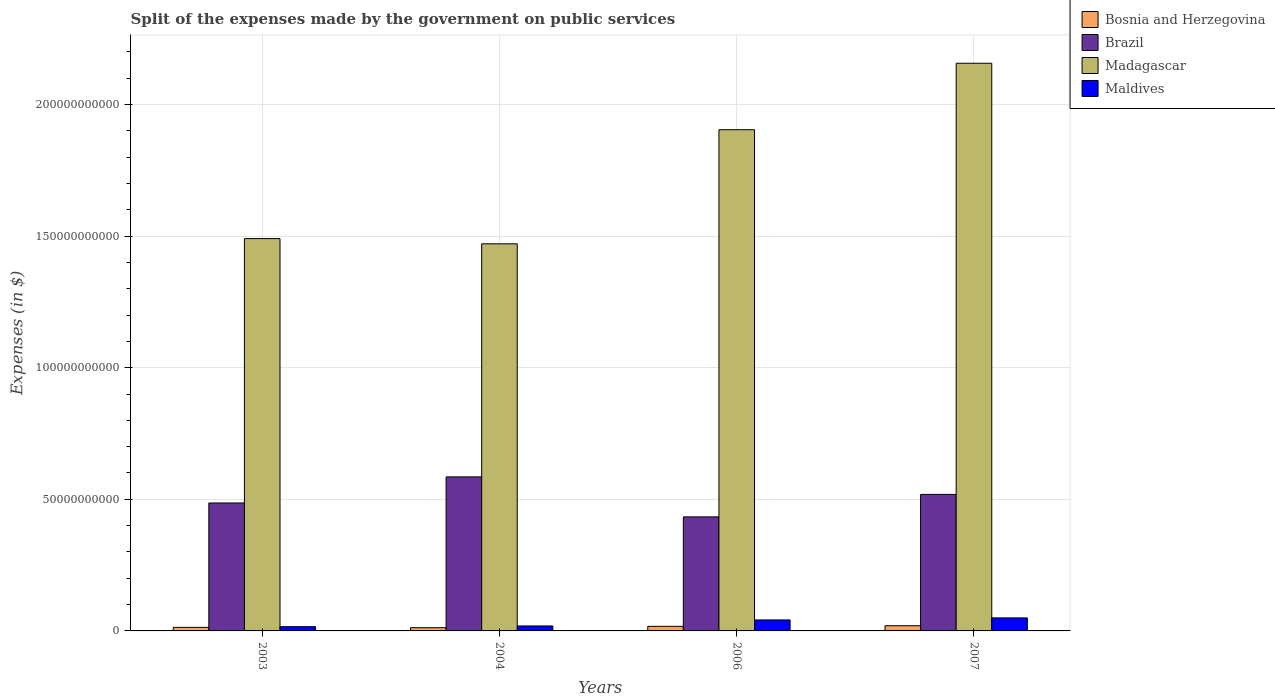How many groups of bars are there?
Provide a succinct answer. 4. Are the number of bars per tick equal to the number of legend labels?
Offer a very short reply. Yes. How many bars are there on the 3rd tick from the right?
Keep it short and to the point. 4. In how many cases, is the number of bars for a given year not equal to the number of legend labels?
Provide a short and direct response. 0. What is the expenses made by the government on public services in Maldives in 2004?
Give a very brief answer. 1.88e+09. Across all years, what is the maximum expenses made by the government on public services in Brazil?
Keep it short and to the point. 5.85e+1. Across all years, what is the minimum expenses made by the government on public services in Madagascar?
Offer a terse response. 1.47e+11. In which year was the expenses made by the government on public services in Madagascar minimum?
Make the answer very short. 2004. What is the total expenses made by the government on public services in Madagascar in the graph?
Ensure brevity in your answer.  7.02e+11. What is the difference between the expenses made by the government on public services in Madagascar in 2006 and that in 2007?
Your response must be concise. -2.52e+1. What is the difference between the expenses made by the government on public services in Brazil in 2007 and the expenses made by the government on public services in Bosnia and Herzegovina in 2003?
Ensure brevity in your answer.  5.05e+1. What is the average expenses made by the government on public services in Bosnia and Herzegovina per year?
Offer a terse response. 1.57e+09. In the year 2006, what is the difference between the expenses made by the government on public services in Brazil and expenses made by the government on public services in Bosnia and Herzegovina?
Your answer should be compact. 4.16e+1. In how many years, is the expenses made by the government on public services in Madagascar greater than 180000000000 $?
Ensure brevity in your answer.  2. What is the ratio of the expenses made by the government on public services in Brazil in 2006 to that in 2007?
Your answer should be very brief. 0.84. Is the expenses made by the government on public services in Maldives in 2006 less than that in 2007?
Offer a very short reply. Yes. Is the difference between the expenses made by the government on public services in Brazil in 2003 and 2004 greater than the difference between the expenses made by the government on public services in Bosnia and Herzegovina in 2003 and 2004?
Your answer should be compact. No. What is the difference between the highest and the second highest expenses made by the government on public services in Brazil?
Ensure brevity in your answer.  6.65e+09. What is the difference between the highest and the lowest expenses made by the government on public services in Madagascar?
Offer a very short reply. 6.86e+1. In how many years, is the expenses made by the government on public services in Madagascar greater than the average expenses made by the government on public services in Madagascar taken over all years?
Your answer should be compact. 2. Is it the case that in every year, the sum of the expenses made by the government on public services in Madagascar and expenses made by the government on public services in Bosnia and Herzegovina is greater than the sum of expenses made by the government on public services in Maldives and expenses made by the government on public services in Brazil?
Provide a short and direct response. Yes. What does the 4th bar from the right in 2003 represents?
Your response must be concise. Bosnia and Herzegovina. Is it the case that in every year, the sum of the expenses made by the government on public services in Maldives and expenses made by the government on public services in Brazil is greater than the expenses made by the government on public services in Madagascar?
Give a very brief answer. No. Are all the bars in the graph horizontal?
Give a very brief answer. No. Where does the legend appear in the graph?
Your answer should be very brief. Top right. How many legend labels are there?
Your answer should be compact. 4. How are the legend labels stacked?
Your response must be concise. Vertical. What is the title of the graph?
Ensure brevity in your answer.  Split of the expenses made by the government on public services. What is the label or title of the Y-axis?
Offer a terse response. Expenses (in $). What is the Expenses (in $) in Bosnia and Herzegovina in 2003?
Your answer should be very brief. 1.35e+09. What is the Expenses (in $) of Brazil in 2003?
Ensure brevity in your answer.  4.86e+1. What is the Expenses (in $) in Madagascar in 2003?
Provide a short and direct response. 1.49e+11. What is the Expenses (in $) of Maldives in 2003?
Give a very brief answer. 1.61e+09. What is the Expenses (in $) in Bosnia and Herzegovina in 2004?
Make the answer very short. 1.22e+09. What is the Expenses (in $) in Brazil in 2004?
Offer a terse response. 5.85e+1. What is the Expenses (in $) in Madagascar in 2004?
Offer a terse response. 1.47e+11. What is the Expenses (in $) in Maldives in 2004?
Offer a terse response. 1.88e+09. What is the Expenses (in $) in Bosnia and Herzegovina in 2006?
Your answer should be compact. 1.74e+09. What is the Expenses (in $) of Brazil in 2006?
Offer a very short reply. 4.33e+1. What is the Expenses (in $) in Madagascar in 2006?
Your answer should be compact. 1.90e+11. What is the Expenses (in $) in Maldives in 2006?
Your answer should be compact. 4.17e+09. What is the Expenses (in $) in Bosnia and Herzegovina in 2007?
Ensure brevity in your answer.  1.98e+09. What is the Expenses (in $) in Brazil in 2007?
Offer a very short reply. 5.19e+1. What is the Expenses (in $) in Madagascar in 2007?
Ensure brevity in your answer.  2.16e+11. What is the Expenses (in $) in Maldives in 2007?
Offer a very short reply. 4.95e+09. Across all years, what is the maximum Expenses (in $) in Bosnia and Herzegovina?
Your answer should be very brief. 1.98e+09. Across all years, what is the maximum Expenses (in $) of Brazil?
Give a very brief answer. 5.85e+1. Across all years, what is the maximum Expenses (in $) of Madagascar?
Provide a short and direct response. 2.16e+11. Across all years, what is the maximum Expenses (in $) in Maldives?
Your answer should be compact. 4.95e+09. Across all years, what is the minimum Expenses (in $) in Bosnia and Herzegovina?
Provide a succinct answer. 1.22e+09. Across all years, what is the minimum Expenses (in $) of Brazil?
Keep it short and to the point. 4.33e+1. Across all years, what is the minimum Expenses (in $) of Madagascar?
Give a very brief answer. 1.47e+11. Across all years, what is the minimum Expenses (in $) of Maldives?
Offer a very short reply. 1.61e+09. What is the total Expenses (in $) of Bosnia and Herzegovina in the graph?
Keep it short and to the point. 6.29e+09. What is the total Expenses (in $) of Brazil in the graph?
Provide a short and direct response. 2.02e+11. What is the total Expenses (in $) in Madagascar in the graph?
Your answer should be very brief. 7.02e+11. What is the total Expenses (in $) of Maldives in the graph?
Keep it short and to the point. 1.26e+1. What is the difference between the Expenses (in $) of Bosnia and Herzegovina in 2003 and that in 2004?
Provide a succinct answer. 1.24e+08. What is the difference between the Expenses (in $) in Brazil in 2003 and that in 2004?
Your answer should be compact. -9.91e+09. What is the difference between the Expenses (in $) in Madagascar in 2003 and that in 2004?
Provide a short and direct response. 1.99e+09. What is the difference between the Expenses (in $) of Maldives in 2003 and that in 2004?
Your answer should be very brief. -2.72e+08. What is the difference between the Expenses (in $) in Bosnia and Herzegovina in 2003 and that in 2006?
Offer a terse response. -3.91e+08. What is the difference between the Expenses (in $) in Brazil in 2003 and that in 2006?
Make the answer very short. 5.28e+09. What is the difference between the Expenses (in $) of Madagascar in 2003 and that in 2006?
Your answer should be very brief. -4.14e+1. What is the difference between the Expenses (in $) of Maldives in 2003 and that in 2006?
Keep it short and to the point. -2.56e+09. What is the difference between the Expenses (in $) in Bosnia and Herzegovina in 2003 and that in 2007?
Keep it short and to the point. -6.30e+08. What is the difference between the Expenses (in $) in Brazil in 2003 and that in 2007?
Keep it short and to the point. -3.26e+09. What is the difference between the Expenses (in $) of Madagascar in 2003 and that in 2007?
Your response must be concise. -6.66e+1. What is the difference between the Expenses (in $) of Maldives in 2003 and that in 2007?
Your answer should be compact. -3.34e+09. What is the difference between the Expenses (in $) of Bosnia and Herzegovina in 2004 and that in 2006?
Your answer should be very brief. -5.15e+08. What is the difference between the Expenses (in $) of Brazil in 2004 and that in 2006?
Ensure brevity in your answer.  1.52e+1. What is the difference between the Expenses (in $) in Madagascar in 2004 and that in 2006?
Offer a terse response. -4.33e+1. What is the difference between the Expenses (in $) of Maldives in 2004 and that in 2006?
Provide a succinct answer. -2.29e+09. What is the difference between the Expenses (in $) in Bosnia and Herzegovina in 2004 and that in 2007?
Provide a short and direct response. -7.55e+08. What is the difference between the Expenses (in $) of Brazil in 2004 and that in 2007?
Your answer should be very brief. 6.65e+09. What is the difference between the Expenses (in $) of Madagascar in 2004 and that in 2007?
Your response must be concise. -6.86e+1. What is the difference between the Expenses (in $) of Maldives in 2004 and that in 2007?
Provide a succinct answer. -3.07e+09. What is the difference between the Expenses (in $) in Bosnia and Herzegovina in 2006 and that in 2007?
Provide a succinct answer. -2.40e+08. What is the difference between the Expenses (in $) in Brazil in 2006 and that in 2007?
Your answer should be compact. -8.54e+09. What is the difference between the Expenses (in $) in Madagascar in 2006 and that in 2007?
Your answer should be compact. -2.52e+1. What is the difference between the Expenses (in $) of Maldives in 2006 and that in 2007?
Your answer should be very brief. -7.75e+08. What is the difference between the Expenses (in $) of Bosnia and Herzegovina in 2003 and the Expenses (in $) of Brazil in 2004?
Give a very brief answer. -5.72e+1. What is the difference between the Expenses (in $) of Bosnia and Herzegovina in 2003 and the Expenses (in $) of Madagascar in 2004?
Make the answer very short. -1.46e+11. What is the difference between the Expenses (in $) of Bosnia and Herzegovina in 2003 and the Expenses (in $) of Maldives in 2004?
Ensure brevity in your answer.  -5.34e+08. What is the difference between the Expenses (in $) in Brazil in 2003 and the Expenses (in $) in Madagascar in 2004?
Keep it short and to the point. -9.84e+1. What is the difference between the Expenses (in $) of Brazil in 2003 and the Expenses (in $) of Maldives in 2004?
Offer a very short reply. 4.67e+1. What is the difference between the Expenses (in $) of Madagascar in 2003 and the Expenses (in $) of Maldives in 2004?
Your answer should be compact. 1.47e+11. What is the difference between the Expenses (in $) of Bosnia and Herzegovina in 2003 and the Expenses (in $) of Brazil in 2006?
Keep it short and to the point. -4.20e+1. What is the difference between the Expenses (in $) of Bosnia and Herzegovina in 2003 and the Expenses (in $) of Madagascar in 2006?
Keep it short and to the point. -1.89e+11. What is the difference between the Expenses (in $) of Bosnia and Herzegovina in 2003 and the Expenses (in $) of Maldives in 2006?
Make the answer very short. -2.83e+09. What is the difference between the Expenses (in $) in Brazil in 2003 and the Expenses (in $) in Madagascar in 2006?
Make the answer very short. -1.42e+11. What is the difference between the Expenses (in $) of Brazil in 2003 and the Expenses (in $) of Maldives in 2006?
Your answer should be very brief. 4.44e+1. What is the difference between the Expenses (in $) of Madagascar in 2003 and the Expenses (in $) of Maldives in 2006?
Keep it short and to the point. 1.45e+11. What is the difference between the Expenses (in $) of Bosnia and Herzegovina in 2003 and the Expenses (in $) of Brazil in 2007?
Give a very brief answer. -5.05e+1. What is the difference between the Expenses (in $) in Bosnia and Herzegovina in 2003 and the Expenses (in $) in Madagascar in 2007?
Provide a succinct answer. -2.14e+11. What is the difference between the Expenses (in $) in Bosnia and Herzegovina in 2003 and the Expenses (in $) in Maldives in 2007?
Provide a short and direct response. -3.60e+09. What is the difference between the Expenses (in $) in Brazil in 2003 and the Expenses (in $) in Madagascar in 2007?
Offer a terse response. -1.67e+11. What is the difference between the Expenses (in $) in Brazil in 2003 and the Expenses (in $) in Maldives in 2007?
Your response must be concise. 4.37e+1. What is the difference between the Expenses (in $) of Madagascar in 2003 and the Expenses (in $) of Maldives in 2007?
Provide a succinct answer. 1.44e+11. What is the difference between the Expenses (in $) of Bosnia and Herzegovina in 2004 and the Expenses (in $) of Brazil in 2006?
Offer a very short reply. -4.21e+1. What is the difference between the Expenses (in $) of Bosnia and Herzegovina in 2004 and the Expenses (in $) of Madagascar in 2006?
Your response must be concise. -1.89e+11. What is the difference between the Expenses (in $) of Bosnia and Herzegovina in 2004 and the Expenses (in $) of Maldives in 2006?
Offer a terse response. -2.95e+09. What is the difference between the Expenses (in $) of Brazil in 2004 and the Expenses (in $) of Madagascar in 2006?
Provide a short and direct response. -1.32e+11. What is the difference between the Expenses (in $) of Brazil in 2004 and the Expenses (in $) of Maldives in 2006?
Your answer should be compact. 5.43e+1. What is the difference between the Expenses (in $) of Madagascar in 2004 and the Expenses (in $) of Maldives in 2006?
Offer a terse response. 1.43e+11. What is the difference between the Expenses (in $) in Bosnia and Herzegovina in 2004 and the Expenses (in $) in Brazil in 2007?
Ensure brevity in your answer.  -5.06e+1. What is the difference between the Expenses (in $) in Bosnia and Herzegovina in 2004 and the Expenses (in $) in Madagascar in 2007?
Your answer should be compact. -2.14e+11. What is the difference between the Expenses (in $) of Bosnia and Herzegovina in 2004 and the Expenses (in $) of Maldives in 2007?
Offer a very short reply. -3.73e+09. What is the difference between the Expenses (in $) in Brazil in 2004 and the Expenses (in $) in Madagascar in 2007?
Provide a succinct answer. -1.57e+11. What is the difference between the Expenses (in $) of Brazil in 2004 and the Expenses (in $) of Maldives in 2007?
Ensure brevity in your answer.  5.36e+1. What is the difference between the Expenses (in $) of Madagascar in 2004 and the Expenses (in $) of Maldives in 2007?
Your answer should be compact. 1.42e+11. What is the difference between the Expenses (in $) of Bosnia and Herzegovina in 2006 and the Expenses (in $) of Brazil in 2007?
Ensure brevity in your answer.  -5.01e+1. What is the difference between the Expenses (in $) of Bosnia and Herzegovina in 2006 and the Expenses (in $) of Madagascar in 2007?
Your response must be concise. -2.14e+11. What is the difference between the Expenses (in $) in Bosnia and Herzegovina in 2006 and the Expenses (in $) in Maldives in 2007?
Keep it short and to the point. -3.21e+09. What is the difference between the Expenses (in $) in Brazil in 2006 and the Expenses (in $) in Madagascar in 2007?
Your answer should be compact. -1.72e+11. What is the difference between the Expenses (in $) of Brazil in 2006 and the Expenses (in $) of Maldives in 2007?
Your answer should be very brief. 3.84e+1. What is the difference between the Expenses (in $) of Madagascar in 2006 and the Expenses (in $) of Maldives in 2007?
Your answer should be very brief. 1.85e+11. What is the average Expenses (in $) in Bosnia and Herzegovina per year?
Give a very brief answer. 1.57e+09. What is the average Expenses (in $) in Brazil per year?
Make the answer very short. 5.06e+1. What is the average Expenses (in $) of Madagascar per year?
Give a very brief answer. 1.76e+11. What is the average Expenses (in $) in Maldives per year?
Provide a short and direct response. 3.15e+09. In the year 2003, what is the difference between the Expenses (in $) in Bosnia and Herzegovina and Expenses (in $) in Brazil?
Make the answer very short. -4.73e+1. In the year 2003, what is the difference between the Expenses (in $) in Bosnia and Herzegovina and Expenses (in $) in Madagascar?
Ensure brevity in your answer.  -1.48e+11. In the year 2003, what is the difference between the Expenses (in $) in Bosnia and Herzegovina and Expenses (in $) in Maldives?
Your response must be concise. -2.63e+08. In the year 2003, what is the difference between the Expenses (in $) in Brazil and Expenses (in $) in Madagascar?
Your response must be concise. -1.00e+11. In the year 2003, what is the difference between the Expenses (in $) of Brazil and Expenses (in $) of Maldives?
Your answer should be very brief. 4.70e+1. In the year 2003, what is the difference between the Expenses (in $) of Madagascar and Expenses (in $) of Maldives?
Give a very brief answer. 1.47e+11. In the year 2004, what is the difference between the Expenses (in $) of Bosnia and Herzegovina and Expenses (in $) of Brazil?
Give a very brief answer. -5.73e+1. In the year 2004, what is the difference between the Expenses (in $) of Bosnia and Herzegovina and Expenses (in $) of Madagascar?
Make the answer very short. -1.46e+11. In the year 2004, what is the difference between the Expenses (in $) of Bosnia and Herzegovina and Expenses (in $) of Maldives?
Your answer should be very brief. -6.59e+08. In the year 2004, what is the difference between the Expenses (in $) of Brazil and Expenses (in $) of Madagascar?
Provide a short and direct response. -8.85e+1. In the year 2004, what is the difference between the Expenses (in $) in Brazil and Expenses (in $) in Maldives?
Keep it short and to the point. 5.66e+1. In the year 2004, what is the difference between the Expenses (in $) in Madagascar and Expenses (in $) in Maldives?
Ensure brevity in your answer.  1.45e+11. In the year 2006, what is the difference between the Expenses (in $) of Bosnia and Herzegovina and Expenses (in $) of Brazil?
Keep it short and to the point. -4.16e+1. In the year 2006, what is the difference between the Expenses (in $) in Bosnia and Herzegovina and Expenses (in $) in Madagascar?
Offer a terse response. -1.89e+11. In the year 2006, what is the difference between the Expenses (in $) of Bosnia and Herzegovina and Expenses (in $) of Maldives?
Your answer should be very brief. -2.44e+09. In the year 2006, what is the difference between the Expenses (in $) of Brazil and Expenses (in $) of Madagascar?
Ensure brevity in your answer.  -1.47e+11. In the year 2006, what is the difference between the Expenses (in $) in Brazil and Expenses (in $) in Maldives?
Your response must be concise. 3.92e+1. In the year 2006, what is the difference between the Expenses (in $) of Madagascar and Expenses (in $) of Maldives?
Offer a very short reply. 1.86e+11. In the year 2007, what is the difference between the Expenses (in $) in Bosnia and Herzegovina and Expenses (in $) in Brazil?
Provide a succinct answer. -4.99e+1. In the year 2007, what is the difference between the Expenses (in $) in Bosnia and Herzegovina and Expenses (in $) in Madagascar?
Give a very brief answer. -2.14e+11. In the year 2007, what is the difference between the Expenses (in $) in Bosnia and Herzegovina and Expenses (in $) in Maldives?
Make the answer very short. -2.97e+09. In the year 2007, what is the difference between the Expenses (in $) of Brazil and Expenses (in $) of Madagascar?
Offer a terse response. -1.64e+11. In the year 2007, what is the difference between the Expenses (in $) of Brazil and Expenses (in $) of Maldives?
Your response must be concise. 4.69e+1. In the year 2007, what is the difference between the Expenses (in $) of Madagascar and Expenses (in $) of Maldives?
Provide a short and direct response. 2.11e+11. What is the ratio of the Expenses (in $) of Bosnia and Herzegovina in 2003 to that in 2004?
Provide a short and direct response. 1.1. What is the ratio of the Expenses (in $) of Brazil in 2003 to that in 2004?
Your response must be concise. 0.83. What is the ratio of the Expenses (in $) in Madagascar in 2003 to that in 2004?
Offer a terse response. 1.01. What is the ratio of the Expenses (in $) of Maldives in 2003 to that in 2004?
Your response must be concise. 0.86. What is the ratio of the Expenses (in $) of Bosnia and Herzegovina in 2003 to that in 2006?
Make the answer very short. 0.78. What is the ratio of the Expenses (in $) of Brazil in 2003 to that in 2006?
Give a very brief answer. 1.12. What is the ratio of the Expenses (in $) of Madagascar in 2003 to that in 2006?
Provide a short and direct response. 0.78. What is the ratio of the Expenses (in $) of Maldives in 2003 to that in 2006?
Provide a succinct answer. 0.39. What is the ratio of the Expenses (in $) in Bosnia and Herzegovina in 2003 to that in 2007?
Your response must be concise. 0.68. What is the ratio of the Expenses (in $) in Brazil in 2003 to that in 2007?
Provide a succinct answer. 0.94. What is the ratio of the Expenses (in $) in Madagascar in 2003 to that in 2007?
Keep it short and to the point. 0.69. What is the ratio of the Expenses (in $) in Maldives in 2003 to that in 2007?
Your answer should be compact. 0.33. What is the ratio of the Expenses (in $) in Bosnia and Herzegovina in 2004 to that in 2006?
Ensure brevity in your answer.  0.7. What is the ratio of the Expenses (in $) in Brazil in 2004 to that in 2006?
Provide a succinct answer. 1.35. What is the ratio of the Expenses (in $) of Madagascar in 2004 to that in 2006?
Your response must be concise. 0.77. What is the ratio of the Expenses (in $) in Maldives in 2004 to that in 2006?
Offer a terse response. 0.45. What is the ratio of the Expenses (in $) of Bosnia and Herzegovina in 2004 to that in 2007?
Offer a terse response. 0.62. What is the ratio of the Expenses (in $) of Brazil in 2004 to that in 2007?
Provide a short and direct response. 1.13. What is the ratio of the Expenses (in $) in Madagascar in 2004 to that in 2007?
Give a very brief answer. 0.68. What is the ratio of the Expenses (in $) in Maldives in 2004 to that in 2007?
Your answer should be compact. 0.38. What is the ratio of the Expenses (in $) of Bosnia and Herzegovina in 2006 to that in 2007?
Offer a very short reply. 0.88. What is the ratio of the Expenses (in $) in Brazil in 2006 to that in 2007?
Your answer should be very brief. 0.84. What is the ratio of the Expenses (in $) in Madagascar in 2006 to that in 2007?
Make the answer very short. 0.88. What is the ratio of the Expenses (in $) in Maldives in 2006 to that in 2007?
Provide a succinct answer. 0.84. What is the difference between the highest and the second highest Expenses (in $) of Bosnia and Herzegovina?
Provide a succinct answer. 2.40e+08. What is the difference between the highest and the second highest Expenses (in $) in Brazil?
Give a very brief answer. 6.65e+09. What is the difference between the highest and the second highest Expenses (in $) in Madagascar?
Provide a succinct answer. 2.52e+1. What is the difference between the highest and the second highest Expenses (in $) of Maldives?
Ensure brevity in your answer.  7.75e+08. What is the difference between the highest and the lowest Expenses (in $) in Bosnia and Herzegovina?
Your answer should be very brief. 7.55e+08. What is the difference between the highest and the lowest Expenses (in $) of Brazil?
Offer a very short reply. 1.52e+1. What is the difference between the highest and the lowest Expenses (in $) of Madagascar?
Make the answer very short. 6.86e+1. What is the difference between the highest and the lowest Expenses (in $) in Maldives?
Offer a terse response. 3.34e+09. 